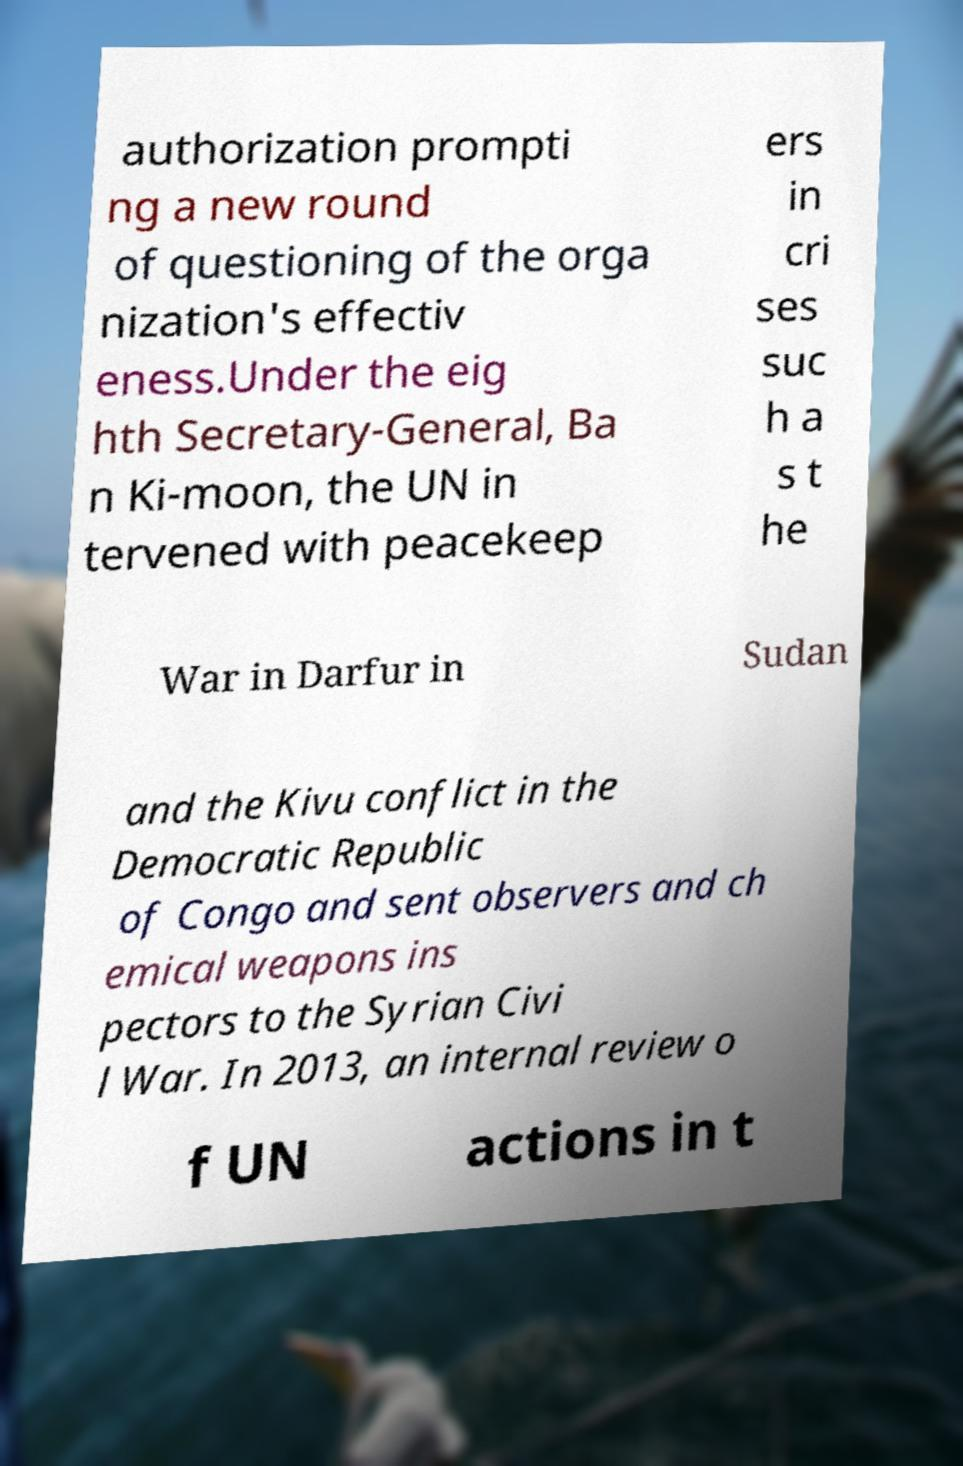Please identify and transcribe the text found in this image. authorization prompti ng a new round of questioning of the orga nization's effectiv eness.Under the eig hth Secretary-General, Ba n Ki-moon, the UN in tervened with peacekeep ers in cri ses suc h a s t he War in Darfur in Sudan and the Kivu conflict in the Democratic Republic of Congo and sent observers and ch emical weapons ins pectors to the Syrian Civi l War. In 2013, an internal review o f UN actions in t 